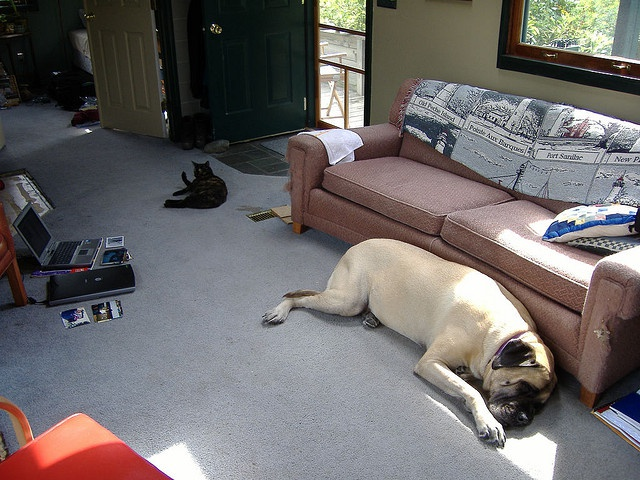Describe the objects in this image and their specific colors. I can see couch in teal, gray, darkgray, black, and maroon tones, dog in teal, darkgray, ivory, tan, and black tones, chair in teal, brown, and salmon tones, laptop in teal, black, gray, and darkblue tones, and laptop in teal, black, and gray tones in this image. 